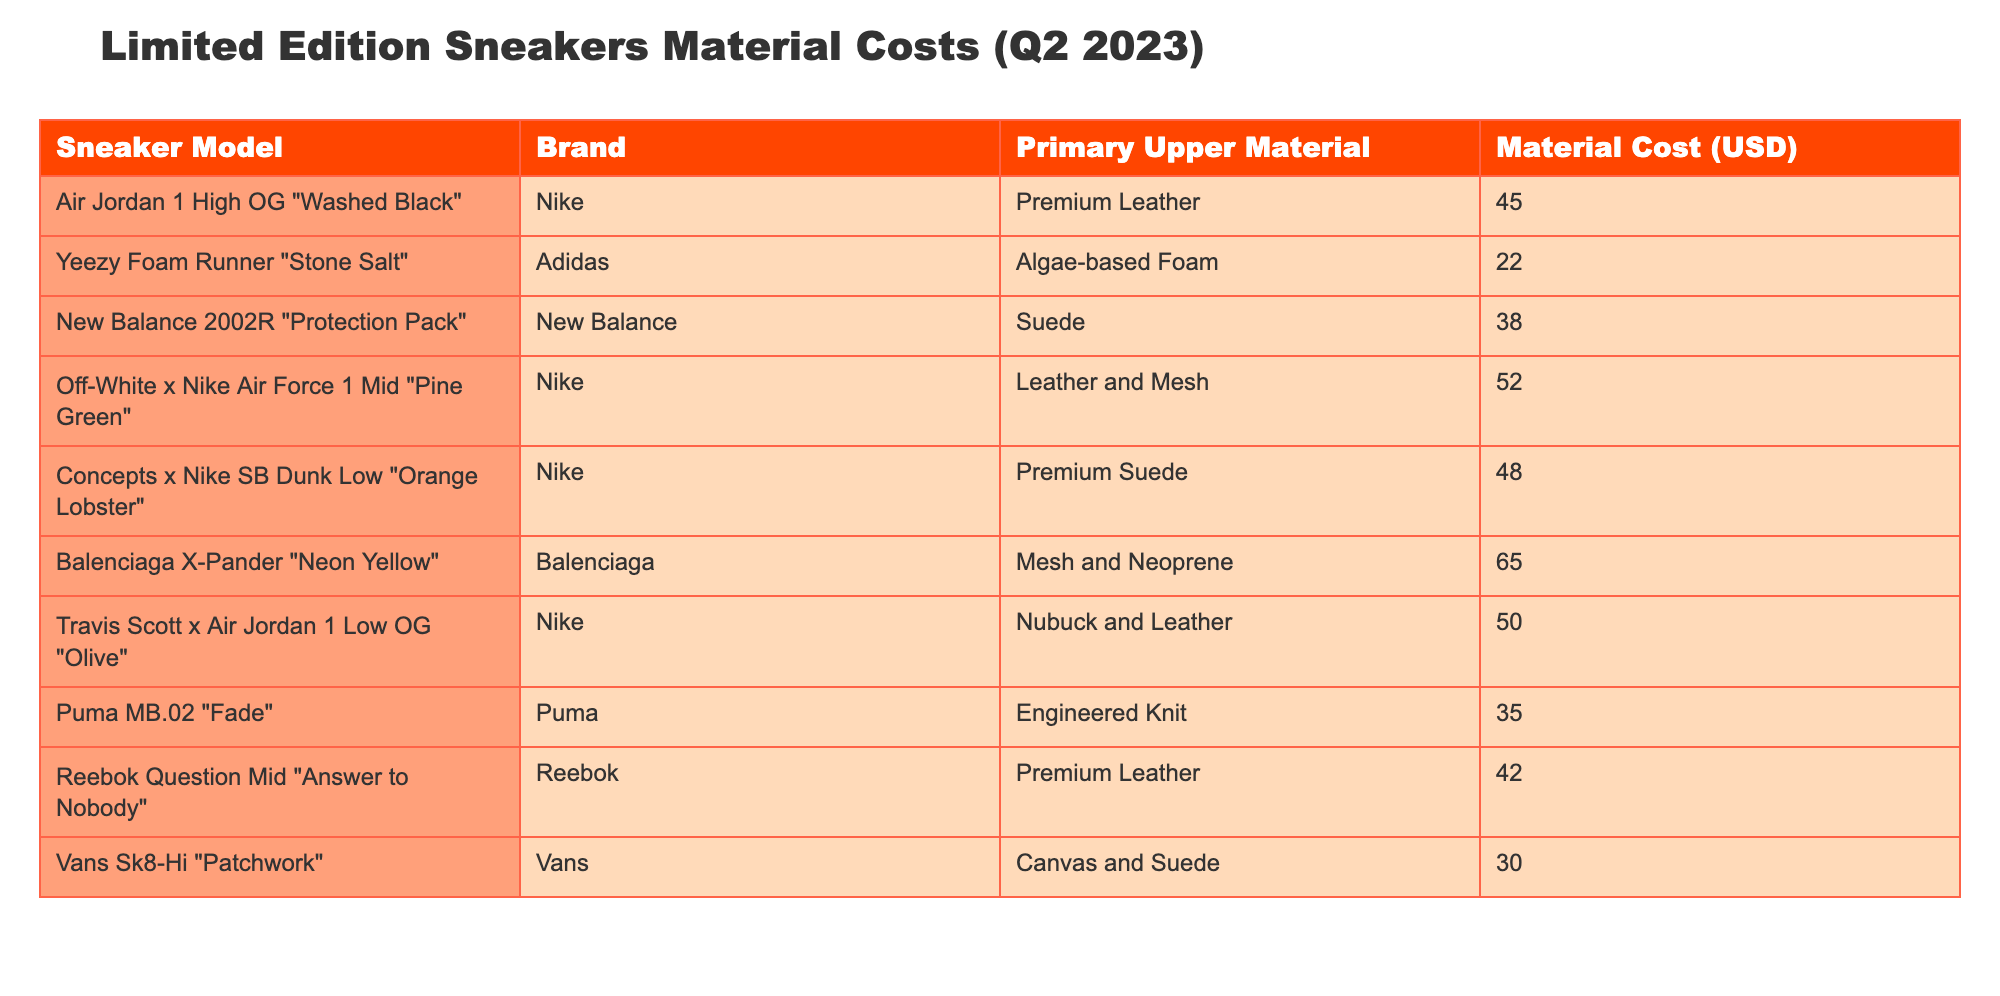What is the material cost of the Yeezy Foam Runner "Stone Salt"? The table lists the Yeezy Foam Runner "Stone Salt" in the row for that sneaker model. In the corresponding column for Material Cost, it shows the cost as 22 USD.
Answer: 22 USD Which sneaker has the highest material cost? By comparing the material costs in the table, we see that the Balenciaga X-Pander "Neon Yellow" has the highest cost at 65 USD compared to all other models listed.
Answer: 65 USD What is the average material cost of the sneakers listed in the table? First, sum all the material costs: 45 + 22 + 38 + 52 + 48 + 65 + 50 + 35 + 42 + 30 =  427 USD. There are 10 sneakers in total, so the average cost is 427/10 = 42.7 USD.
Answer: 42.7 USD Is the material cost of the New Balance 2002R "Protection Pack" greater than 40 USD? The material cost for the New Balance 2002R "Protection Pack" is listed as 38 USD, which is less than 40 USD. Therefore, the answer is no.
Answer: No How many sneakers have a material cost less than 40 USD? Looking through the table, the sneakers with a cost less than 40 USD are Yeezy Foam Runner "Stone Salt" (22), Puma MB.02 "Fade" (35), and Vans Sk8-Hi "Patchwork" (30). There are 3 sneakers that meet this criterion.
Answer: 3 